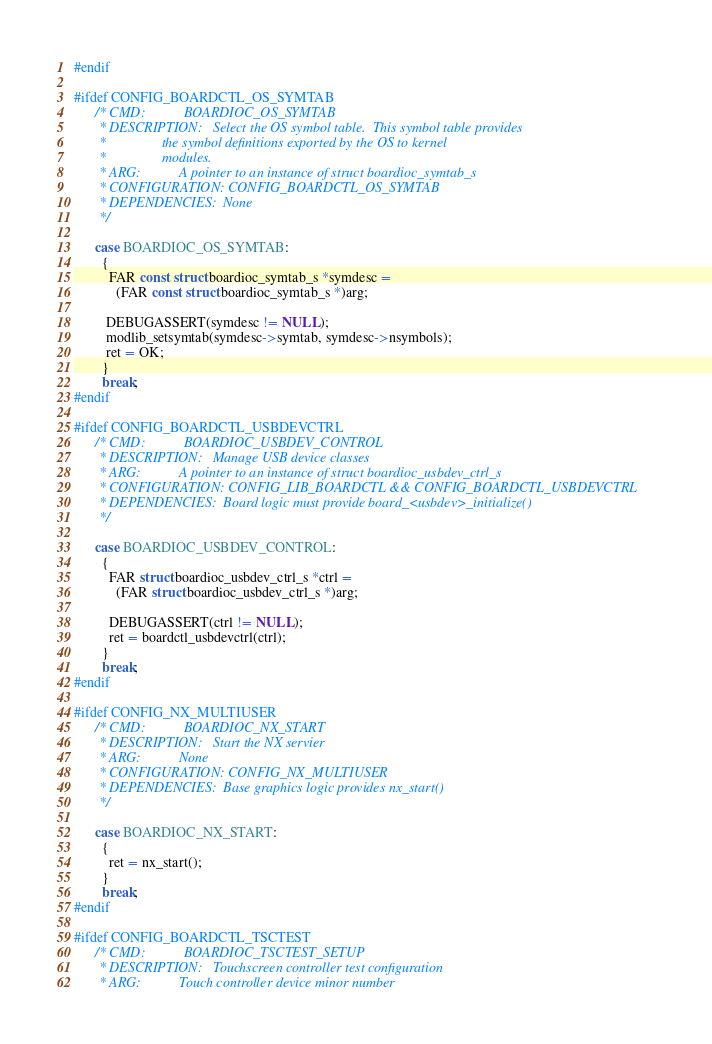<code> <loc_0><loc_0><loc_500><loc_500><_C_>#endif

#ifdef CONFIG_BOARDCTL_OS_SYMTAB
      /* CMD:           BOARDIOC_OS_SYMTAB
       * DESCRIPTION:   Select the OS symbol table.  This symbol table provides
       *                the symbol definitions exported by the OS to kernel
       *                modules.
       * ARG:           A pointer to an instance of struct boardioc_symtab_s
       * CONFIGURATION: CONFIG_BOARDCTL_OS_SYMTAB
       * DEPENDENCIES:  None
       */

      case BOARDIOC_OS_SYMTAB:
        {
          FAR const struct boardioc_symtab_s *symdesc =
            (FAR const struct boardioc_symtab_s *)arg;

         DEBUGASSERT(symdesc != NULL);
         modlib_setsymtab(symdesc->symtab, symdesc->nsymbols);
         ret = OK;
        }
        break;
#endif

#ifdef CONFIG_BOARDCTL_USBDEVCTRL
      /* CMD:           BOARDIOC_USBDEV_CONTROL
       * DESCRIPTION:   Manage USB device classes
       * ARG:           A pointer to an instance of struct boardioc_usbdev_ctrl_s
       * CONFIGURATION: CONFIG_LIB_BOARDCTL && CONFIG_BOARDCTL_USBDEVCTRL
       * DEPENDENCIES:  Board logic must provide board_<usbdev>_initialize()
       */

      case BOARDIOC_USBDEV_CONTROL:
        {
          FAR struct boardioc_usbdev_ctrl_s *ctrl =
            (FAR struct boardioc_usbdev_ctrl_s *)arg;

          DEBUGASSERT(ctrl != NULL);
          ret = boardctl_usbdevctrl(ctrl);
        }
        break;
#endif

#ifdef CONFIG_NX_MULTIUSER
      /* CMD:           BOARDIOC_NX_START
       * DESCRIPTION:   Start the NX servier
       * ARG:           None
       * CONFIGURATION: CONFIG_NX_MULTIUSER
       * DEPENDENCIES:  Base graphics logic provides nx_start()
       */

      case BOARDIOC_NX_START:
        {
          ret = nx_start();
        }
        break;
#endif

#ifdef CONFIG_BOARDCTL_TSCTEST
      /* CMD:           BOARDIOC_TSCTEST_SETUP
       * DESCRIPTION:   Touchscreen controller test configuration
       * ARG:           Touch controller device minor number</code> 